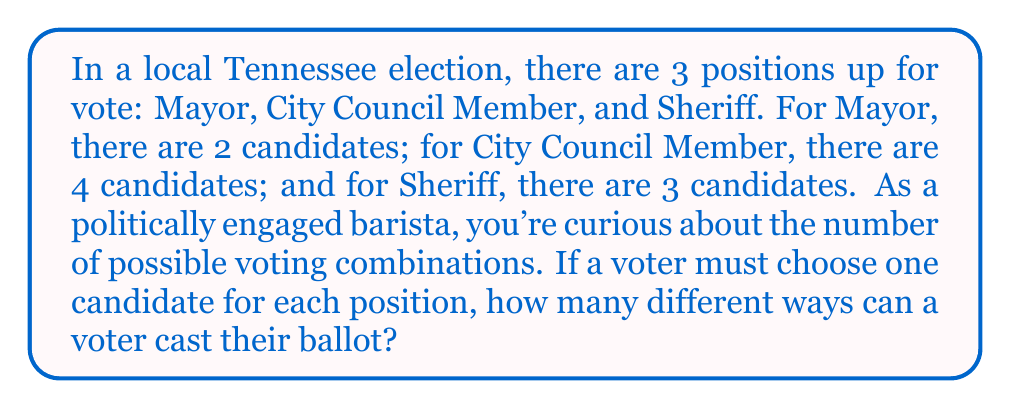Solve this math problem. To solve this problem, we'll use the multiplication principle of counting. Here's the step-by-step solution:

1. For the Mayor position:
   - There are 2 candidates to choose from
   - A voter has 2 options for this position

2. For the City Council Member position:
   - There are 4 candidates to choose from
   - A voter has 4 options for this position

3. For the Sheriff position:
   - There are 3 candidates to choose from
   - A voter has 3 options for this position

4. To find the total number of possible voting combinations, we multiply the number of options for each position:

   $$ \text{Total combinations} = \text{Mayor options} \times \text{City Council options} \times \text{Sheriff options} $$
   $$ \text{Total combinations} = 2 \times 4 \times 3 $$
   $$ \text{Total combinations} = 24 $$

Therefore, there are 24 different ways a voter can cast their ballot in this local Tennessee election.
Answer: 24 